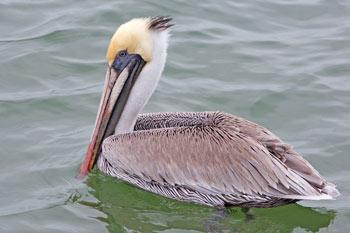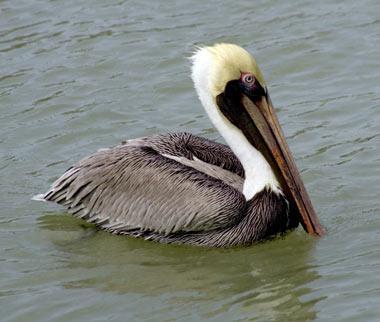The first image is the image on the left, the second image is the image on the right. Given the left and right images, does the statement "The right image shows a pelican afloat on the water." hold true? Answer yes or no. Yes. 